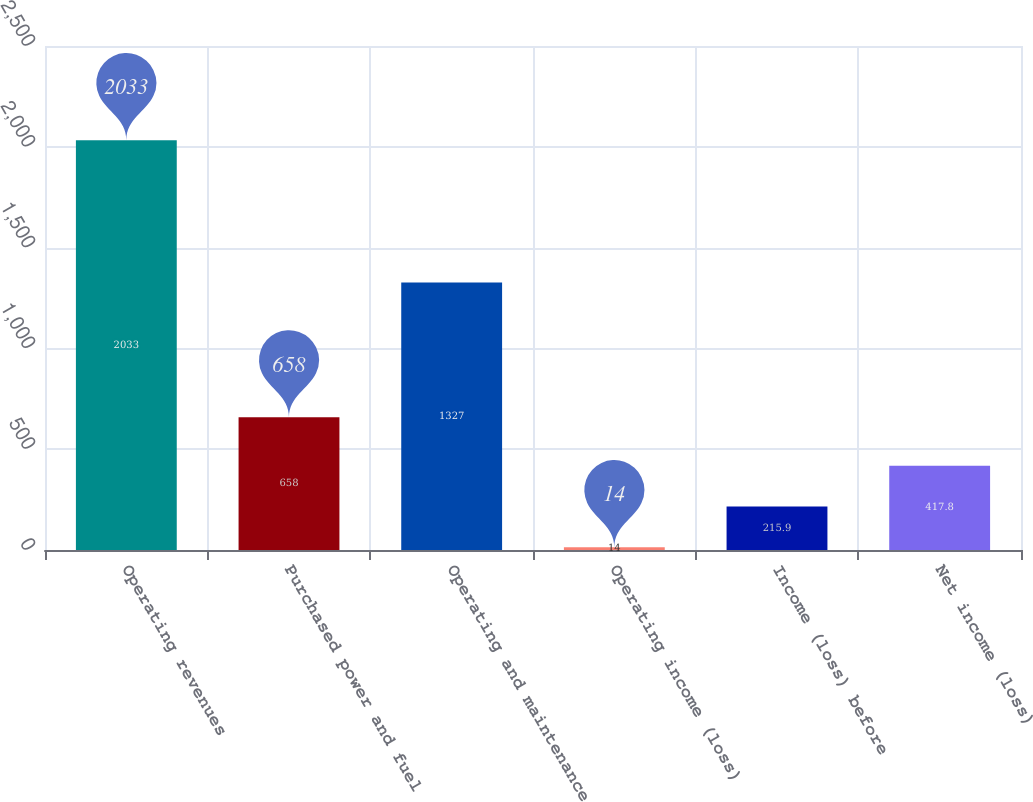Convert chart to OTSL. <chart><loc_0><loc_0><loc_500><loc_500><bar_chart><fcel>Operating revenues<fcel>Purchased power and fuel<fcel>Operating and maintenance<fcel>Operating income (loss)<fcel>Income (loss) before<fcel>Net income (loss)<nl><fcel>2033<fcel>658<fcel>1327<fcel>14<fcel>215.9<fcel>417.8<nl></chart> 